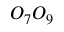<formula> <loc_0><loc_0><loc_500><loc_500>O _ { 7 } O _ { 9 }</formula> 